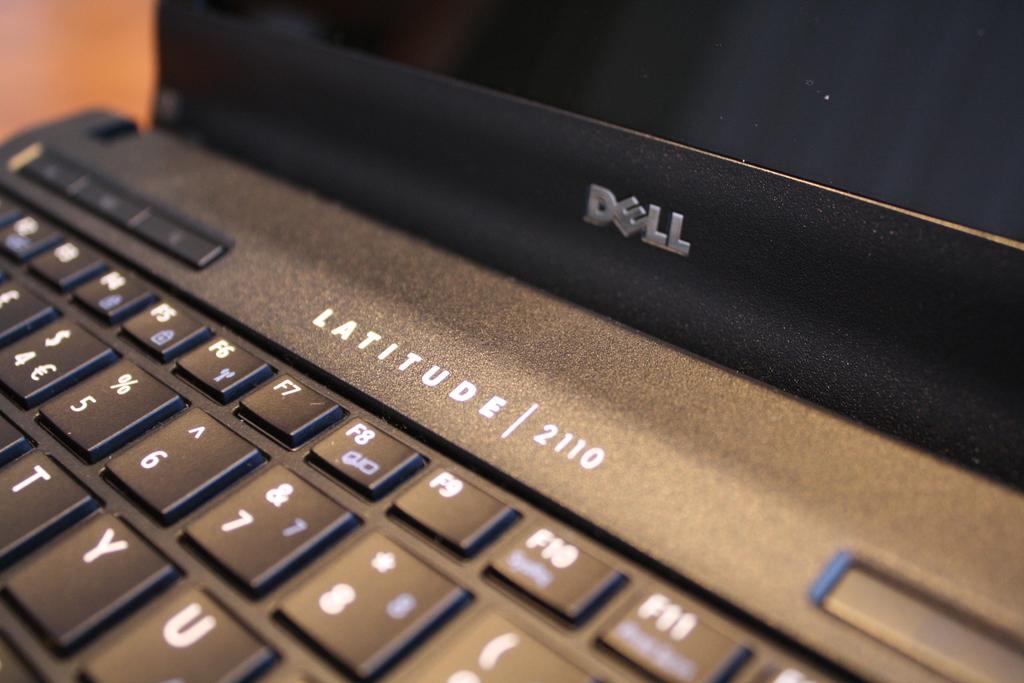What brand of computer?
Make the answer very short. Dell. 